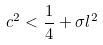Convert formula to latex. <formula><loc_0><loc_0><loc_500><loc_500>c ^ { 2 } < \frac { 1 } { 4 } + \sigma l ^ { 2 }</formula> 